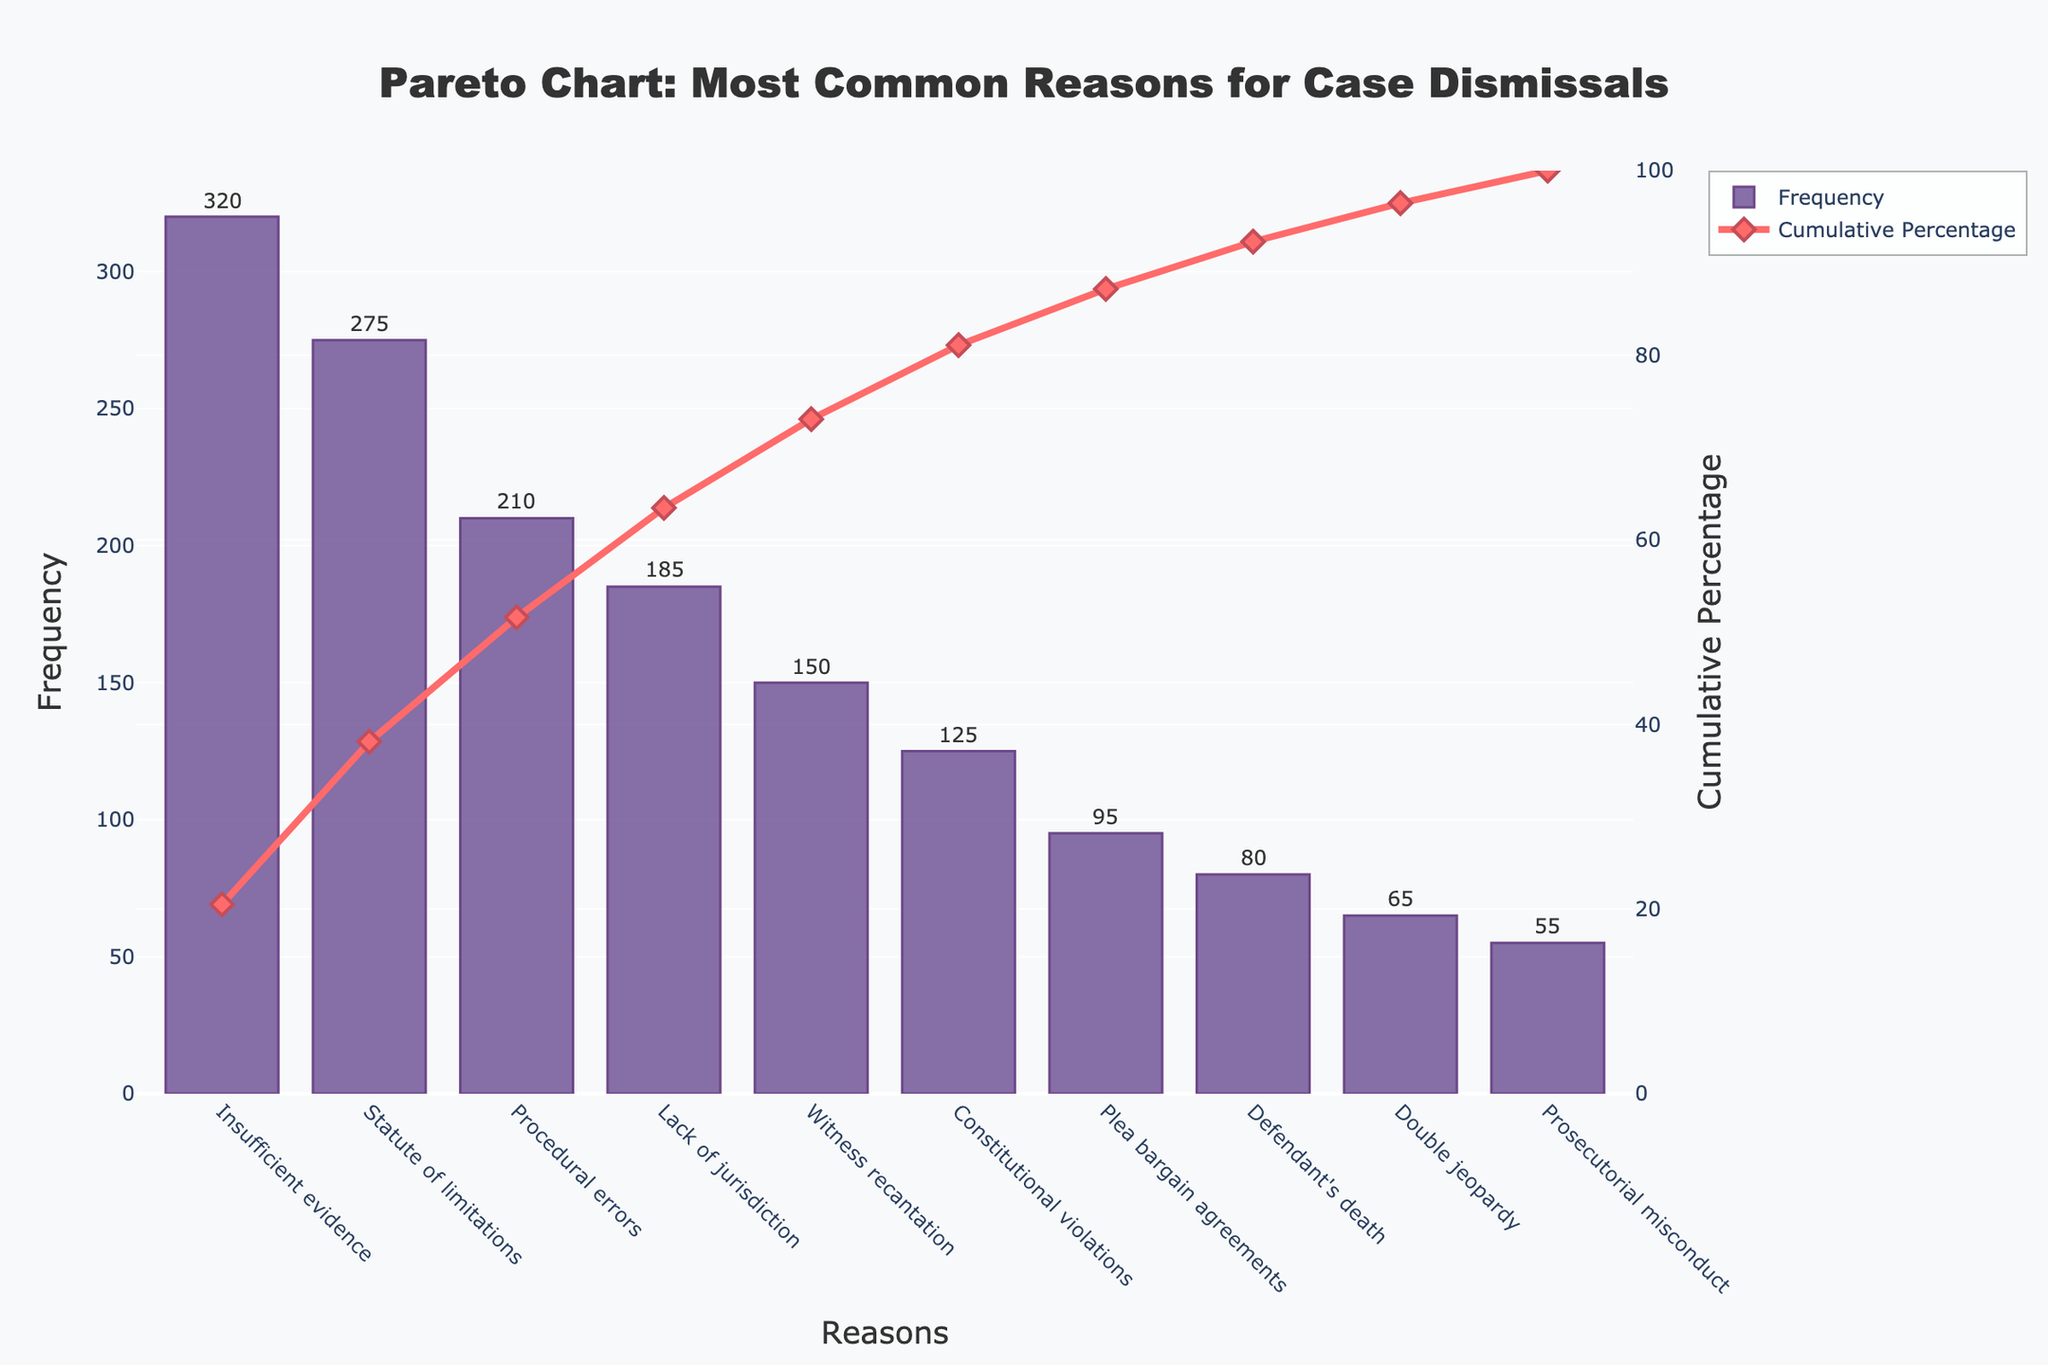What is the title of the Pareto chart? The title of the Pareto chart is located at the top center of the figure, which can be read directly.
Answer: Pareto Chart: Most Common Reasons for Case Dismissals What is the most common reason for case dismissals? The most common reason for case dismissals can be identified as the reason with the highest bar on the chart.
Answer: Insufficient evidence How many reasons account for more than 50% of case dismissals? To determine how many reasons account for more than 50% of case dismissals, look at the line representing the cumulative percentage and find where it crosses 50% on the y-axis.
Answer: Three Which reason has the lowest frequency? The reason with the lowest frequency is represented by the shortest bar in the chart.
Answer: Prosecutorial misconduct Compare the frequencies of "Lack of jurisdiction" and "Procedural errors". Which one is higher and by how much? To compare the frequencies of "Lack of jurisdiction" and "Procedural errors", subtract the frequency of the lesser from the greater.
Answer: Procedural errors is higher by 25 What percentage of case dismissals does "Witness recantation" account for? To find the percentage for "Witness recantation", divide its frequency by the total frequency of all reasons, then multiply by 100.
Answer: 12.8% What is the cumulative percentage up to "Constitutional violations"? The cumulative percentage up to a specific reason is indicated by the y2-axis value on the line plot corresponding to that reason.
Answer: 92.5% How does the cumulative percentage change between "Lack of jurisdiction" and "Witness recantation"? To see how the cumulative percentage changes, subtract the cumulative percentage value of "Lack of jurisdiction" from that of "Witness recantation".
Answer: It increases by 15% Rank the top three reasons in terms of frequency. To rank the top three reasons, list them in order from highest to lowest frequency based on the bar heights.
Answer: Insufficient evidence, Statute of limitations, Procedural errors How many cumulative percentages are higher than 90%? Count the points on the cumulative percentage line plot that exceed 90% on the y2-axis.
Answer: Two 